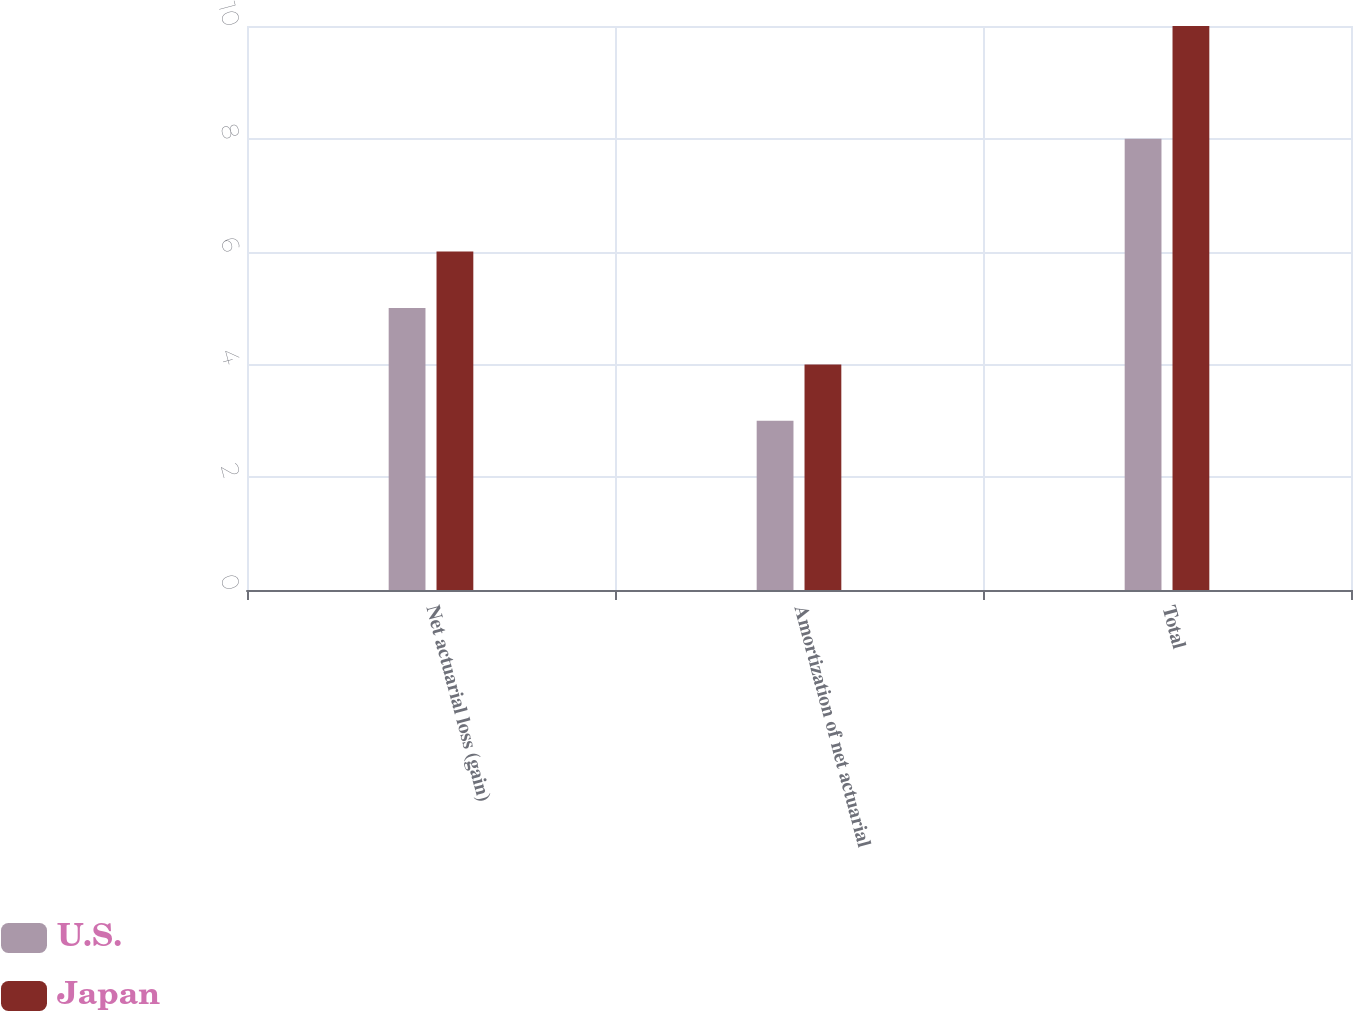<chart> <loc_0><loc_0><loc_500><loc_500><stacked_bar_chart><ecel><fcel>Net actuarial loss (gain)<fcel>Amortization of net actuarial<fcel>Total<nl><fcel>U.S.<fcel>5<fcel>3<fcel>8<nl><fcel>Japan<fcel>6<fcel>4<fcel>10<nl></chart> 